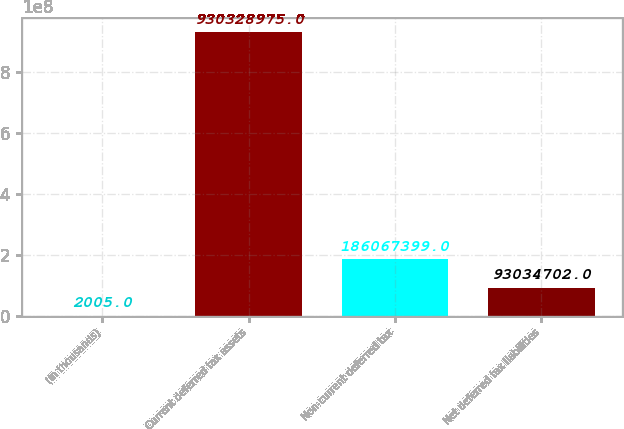<chart> <loc_0><loc_0><loc_500><loc_500><bar_chart><fcel>(In thousands)<fcel>Current deferred tax assets<fcel>Non-current deferred tax<fcel>Net deferred tax liabilities<nl><fcel>2005<fcel>9.30329e+08<fcel>1.86067e+08<fcel>9.30347e+07<nl></chart> 